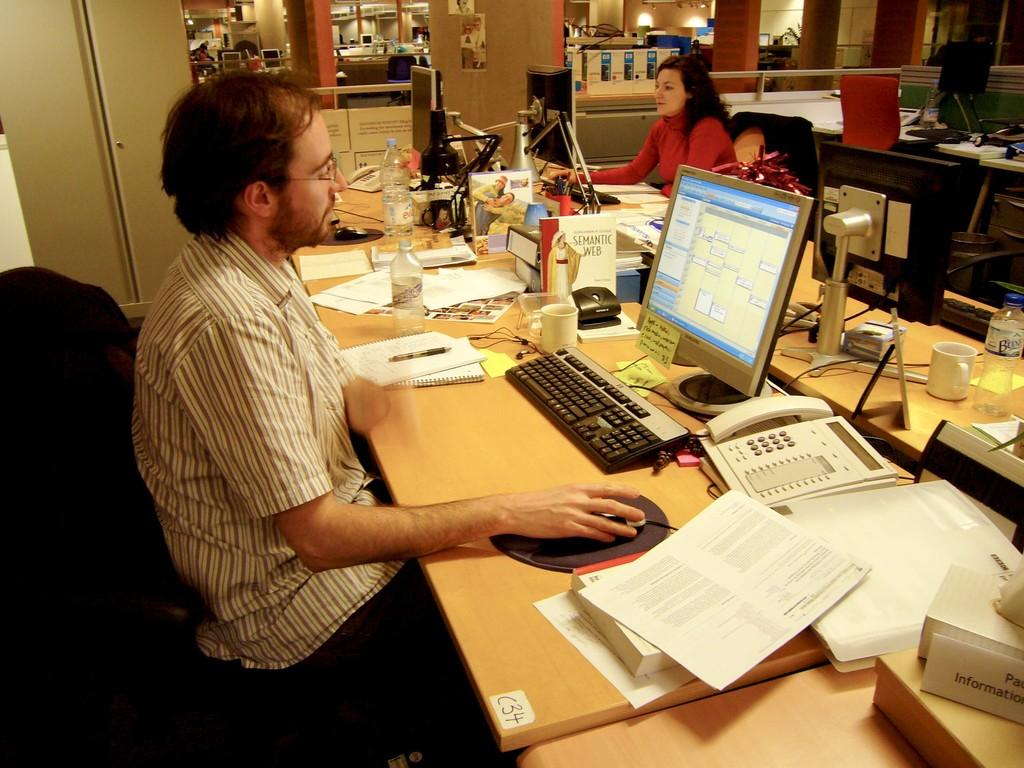<image>
Render a clear and concise summary of the photo. A man sitting at a desk on a computer with a sticker placed on the edge of the desk that has C34 written on it 